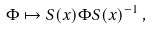<formula> <loc_0><loc_0><loc_500><loc_500>\Phi \mapsto S ( x ) \Phi S ( x ) ^ { - 1 } \, ,</formula> 